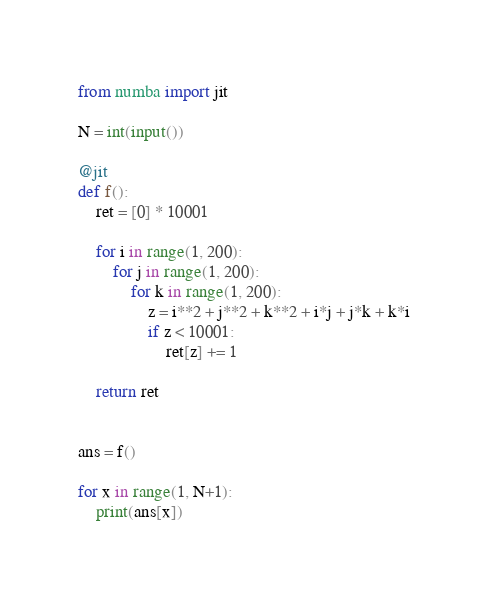<code> <loc_0><loc_0><loc_500><loc_500><_Python_>from numba import jit

N = int(input())

@jit
def f():
    ret = [0] * 10001

    for i in range(1, 200):
        for j in range(1, 200):
            for k in range(1, 200):
                z = i**2 + j**2 + k**2 + i*j + j*k + k*i
                if z < 10001:
                    ret[z] += 1

    return ret


ans = f()

for x in range(1, N+1):
    print(ans[x])
</code> 